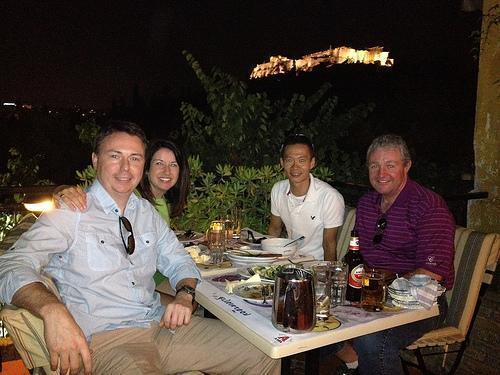How many people in the picture?
Give a very brief answer. 4. How many men in the picture?
Give a very brief answer. 3. How many women in the photo?
Give a very brief answer. 1. How many people are smiling?
Give a very brief answer. 4. How many hands can you see in the photo?
Give a very brief answer. 3. 